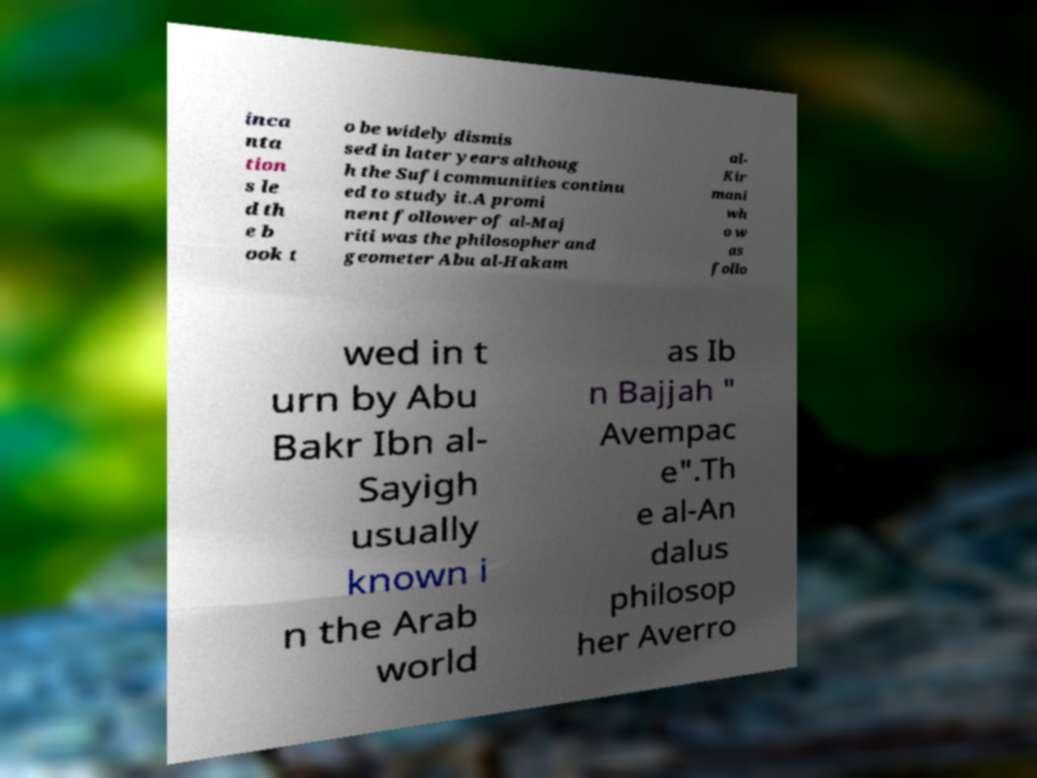I need the written content from this picture converted into text. Can you do that? inca nta tion s le d th e b ook t o be widely dismis sed in later years althoug h the Sufi communities continu ed to study it.A promi nent follower of al-Maj riti was the philosopher and geometer Abu al-Hakam al- Kir mani wh o w as follo wed in t urn by Abu Bakr Ibn al- Sayigh usually known i n the Arab world as Ib n Bajjah " Avempac e".Th e al-An dalus philosop her Averro 